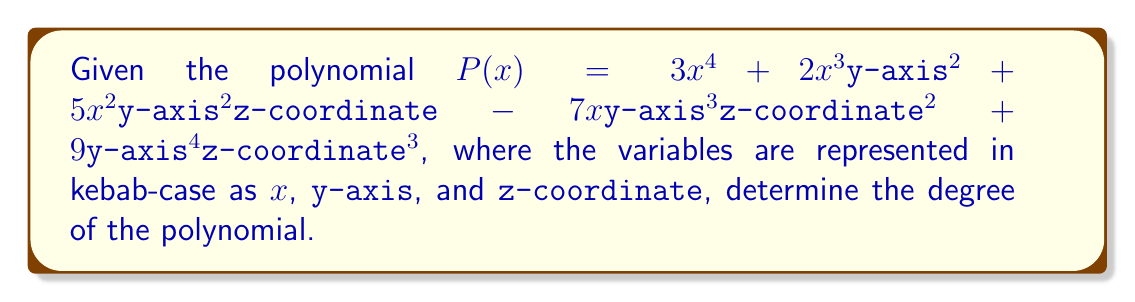Give your solution to this math problem. To determine the degree of a polynomial with multiple variables, we need to follow these steps:

1. Identify the degree of each term:
   - $3x^4$: degree = 4
   - $2x^3y^2$: degree = 3 + 2 = 5
   - $5x^2y^2z$: degree = 2 + 2 + 1 = 5
   - $-7xy^3z^2$: degree = 1 + 3 + 2 = 6
   - $9y^4z^3$: degree = 4 + 3 = 7

2. Find the maximum degree among all terms:
   The highest degree is 7, which corresponds to the term $9y^4z^3$.

3. Translate variables to kebab-case:
   - x remains x
   - y becomes y-axis
   - z becomes z-coordinate

Therefore, the degree of the polynomial $P(x, \text{y-axis}, \text{z-coordinate})$ is 7.
Answer: 7 